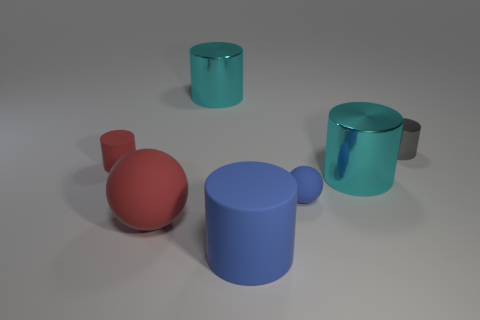What material is the cyan object that is behind the small object that is on the left side of the small blue thing made of?
Your response must be concise. Metal. There is a rubber thing that is the same color as the tiny ball; what shape is it?
Keep it short and to the point. Cylinder. The blue thing that is the same size as the red cylinder is what shape?
Offer a terse response. Sphere. Is the number of tiny gray metal objects less than the number of red things?
Provide a succinct answer. Yes. Are there any gray shiny things to the right of the matte object that is behind the tiny sphere?
Offer a terse response. Yes. What is the shape of the blue thing that is made of the same material as the small ball?
Make the answer very short. Cylinder. Are there any other things that have the same color as the big ball?
Keep it short and to the point. Yes. There is a tiny gray object that is the same shape as the small red matte thing; what material is it?
Make the answer very short. Metal. What number of other things are the same size as the red rubber sphere?
Your answer should be compact. 3. What is the size of the sphere that is the same color as the small matte cylinder?
Your answer should be compact. Large. 